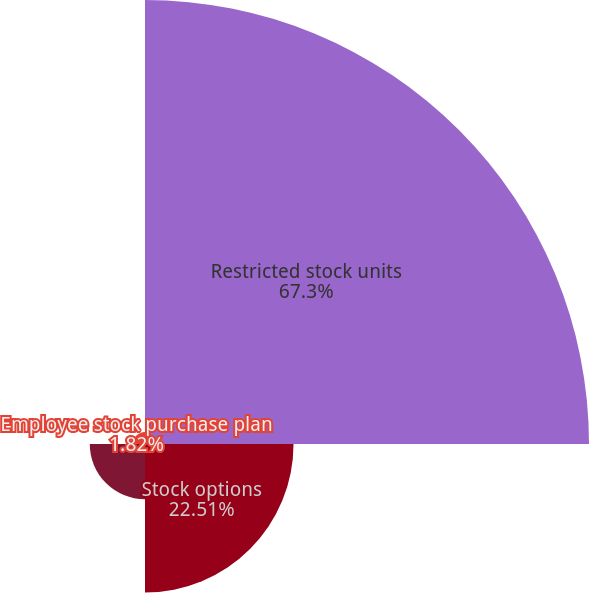<chart> <loc_0><loc_0><loc_500><loc_500><pie_chart><fcel>Restricted stock units<fcel>Stock options<fcel>Restricted stock<fcel>Employee stock purchase plan<nl><fcel>67.29%<fcel>22.51%<fcel>8.37%<fcel>1.82%<nl></chart> 